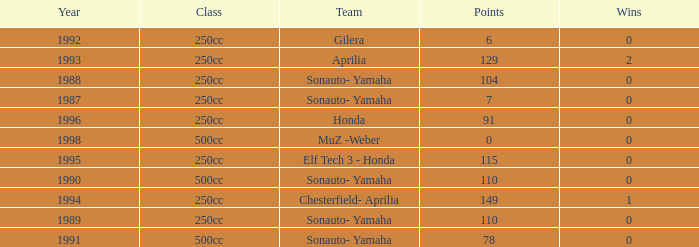What is the highest number of points the team with 0 wins had before 1992? 110.0. 